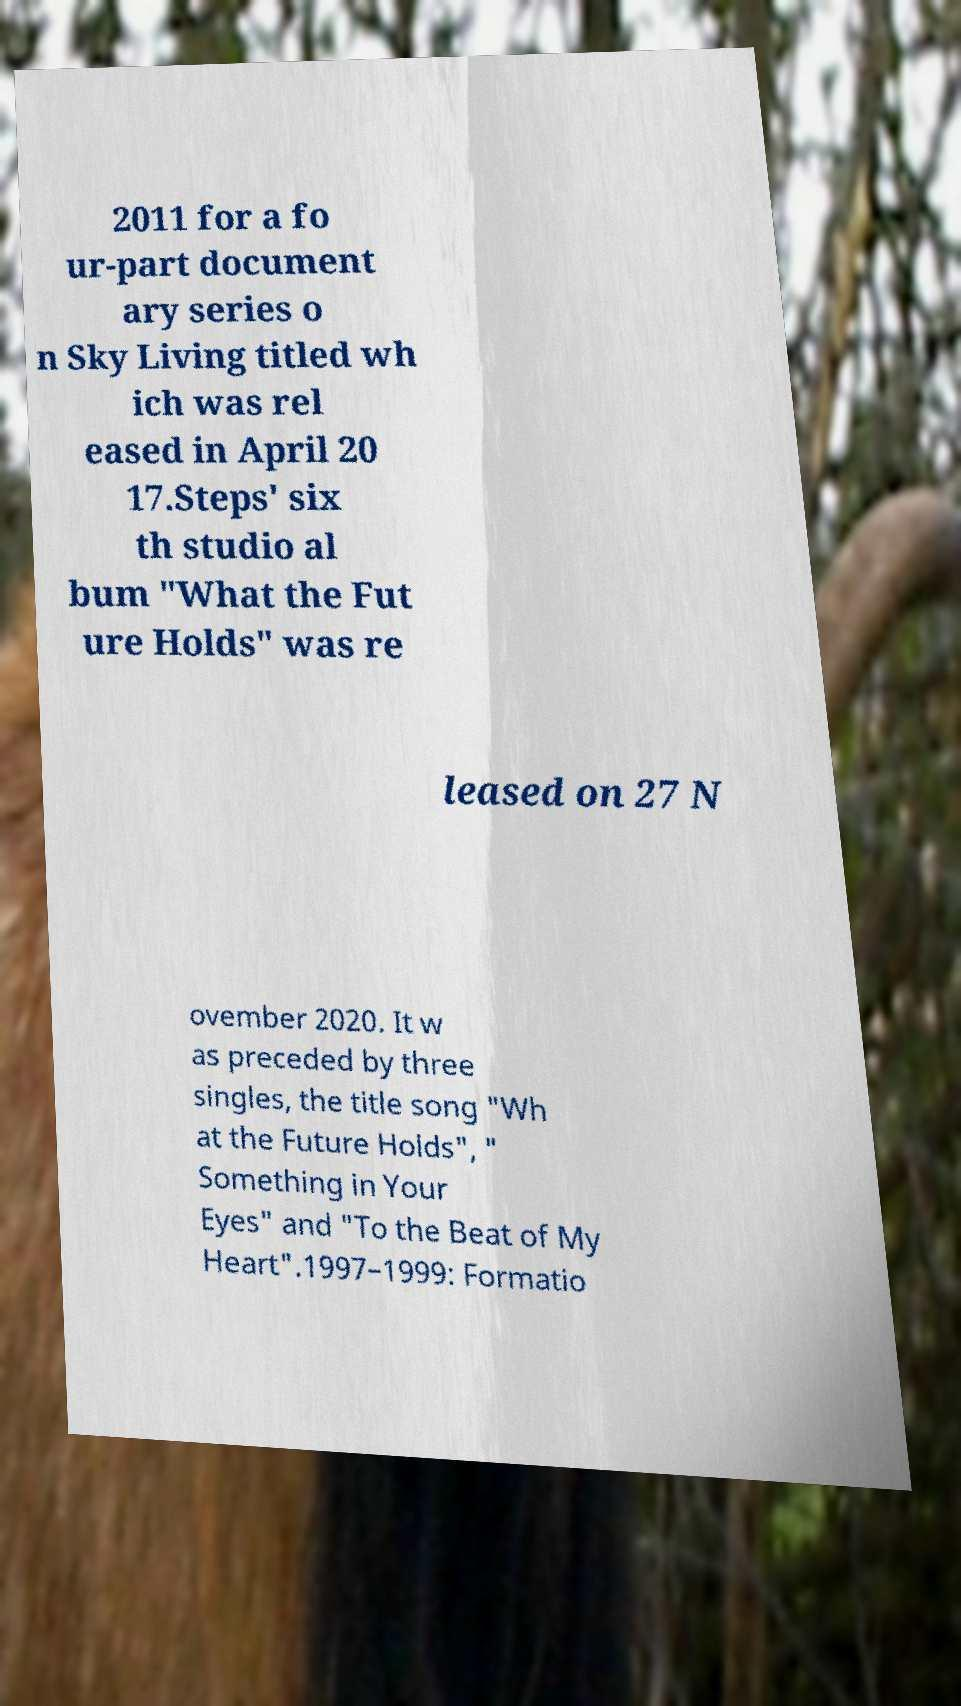What messages or text are displayed in this image? I need them in a readable, typed format. 2011 for a fo ur-part document ary series o n Sky Living titled wh ich was rel eased in April 20 17.Steps' six th studio al bum "What the Fut ure Holds" was re leased on 27 N ovember 2020. It w as preceded by three singles, the title song "Wh at the Future Holds", " Something in Your Eyes" and "To the Beat of My Heart".1997–1999: Formatio 